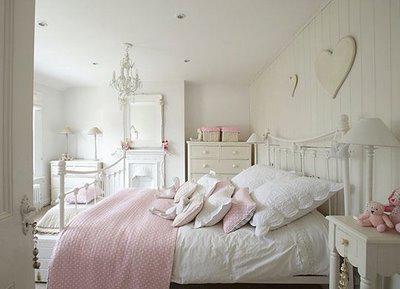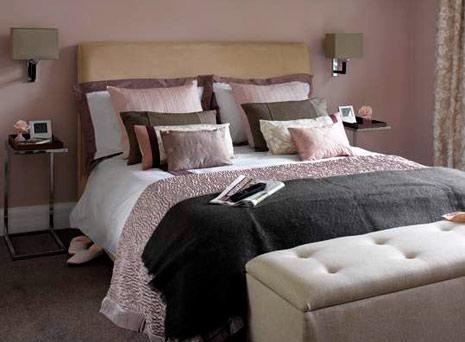The first image is the image on the left, the second image is the image on the right. For the images shown, is this caption "One image contains at least six full-size all white bed pillows." true? Answer yes or no. No. The first image is the image on the left, the second image is the image on the right. Analyze the images presented: Is the assertion "There is at least one human lying on a bed." valid? Answer yes or no. No. 